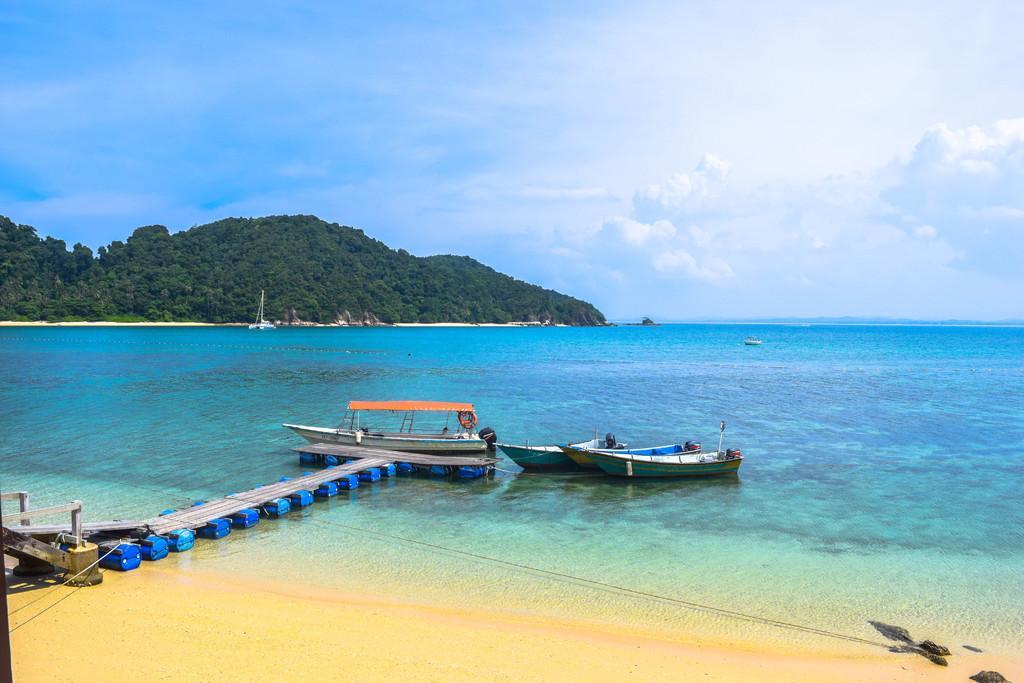How would you summarize this image in a sentence or two? In this picture we can see boats above the water and walkway. In the background of the image we can see trees and sky with clouds. 